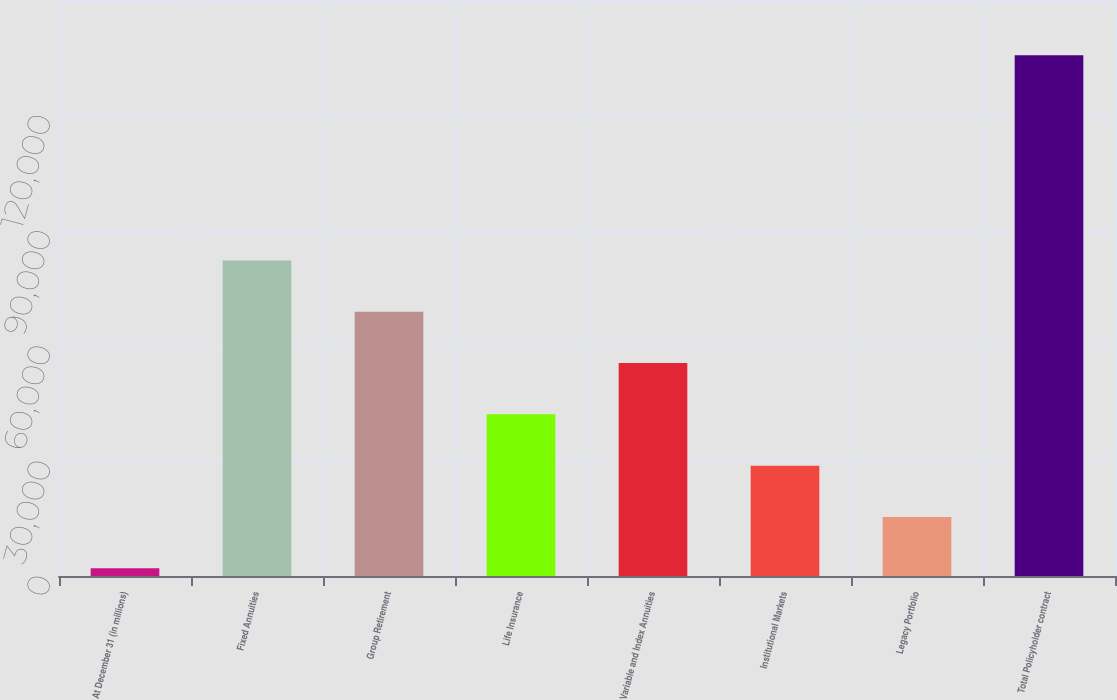<chart> <loc_0><loc_0><loc_500><loc_500><bar_chart><fcel>At December 31 (in millions)<fcel>Fixed Annuities<fcel>Group Retirement<fcel>Life Insurance<fcel>Variable and Index Annuities<fcel>Institutional Markets<fcel>Legacy Portfolio<fcel>Total Policyholder contract<nl><fcel>2017<fcel>82168<fcel>68809.5<fcel>42092.5<fcel>55451<fcel>28734<fcel>15375.5<fcel>135602<nl></chart> 